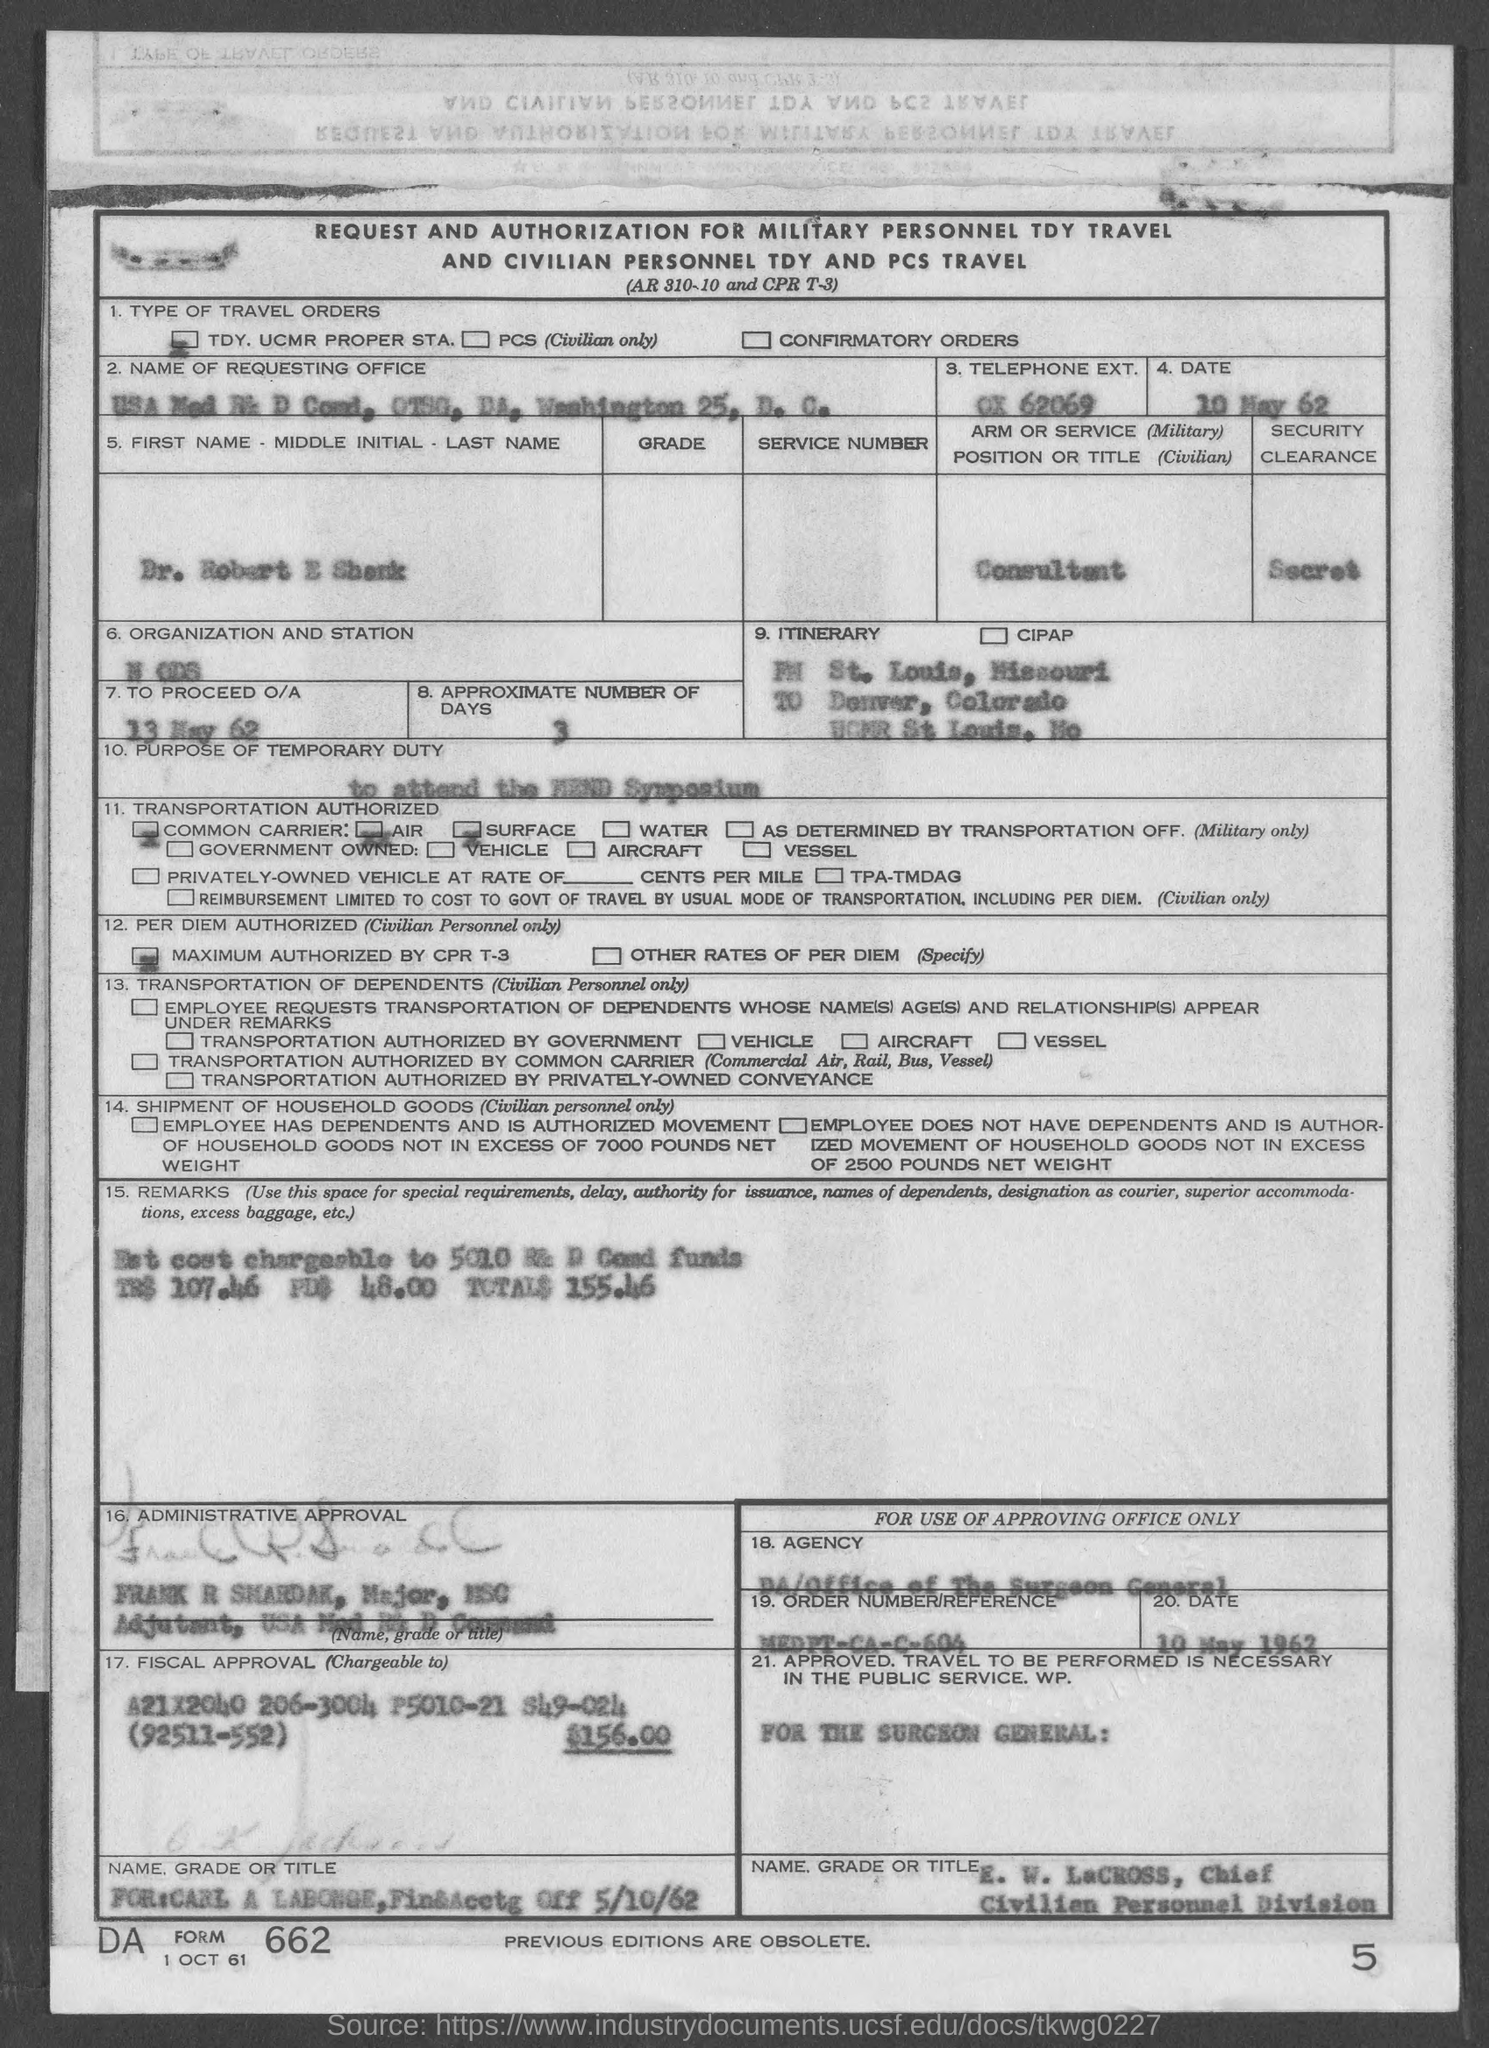Mention the heading of the form?
Give a very brief answer. REQUEST AND AUTHORIZATION FOR MILITARY PERSONNEL TDY TRAVEL AND CIVILIAN PERSONNEL TDY AND PCS TRAVEL. Provide the "DATE" mentioned in the form?
Offer a very short reply. 10 MAY 1962. What is the "TELEPHONE EXT." given?
Make the answer very short. OX 62069. Provide the "POSITION OR TITLE (Civilian)" given?
Make the answer very short. Consultant. What is the "SECURITY CLEARANCE" mentioned in the form?
Your response must be concise. Secret. What is the "TO PROCEED O/A" mentioned in the form?
Your answer should be compact. 13 may 62. What is the "APPROXIMATE NUMBER OF DAYS" mentioned in the form?
Offer a terse response. 3. Mention the "FORM" number given at left bottom corner of the form?
Offer a terse response. 662. What is the "TOTAL" amount mentioned against "REMARKS"?
Offer a very short reply. $155.46. Mention the page number given at right bottom corner of the form?
Ensure brevity in your answer.  5. 